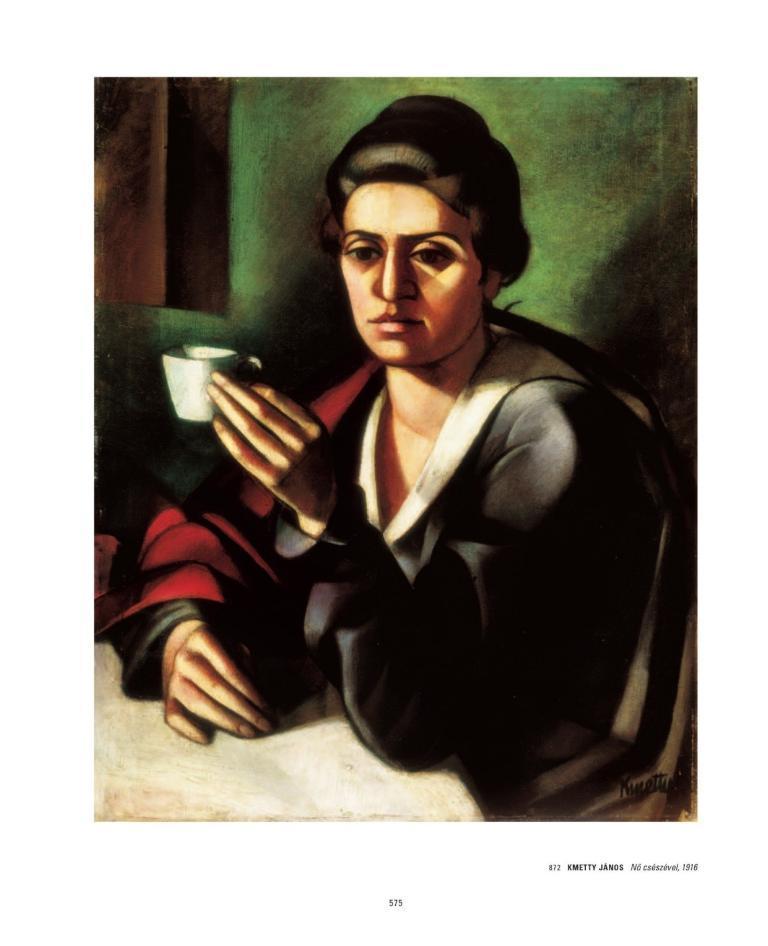Can you describe this image briefly? In this picture we can see painting. There is a woman sitting on a chair and holding a cup and we can see table, behind her we can see wall. At the bottom of the image we can see text and numbers. 